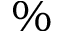<formula> <loc_0><loc_0><loc_500><loc_500>\%</formula> 